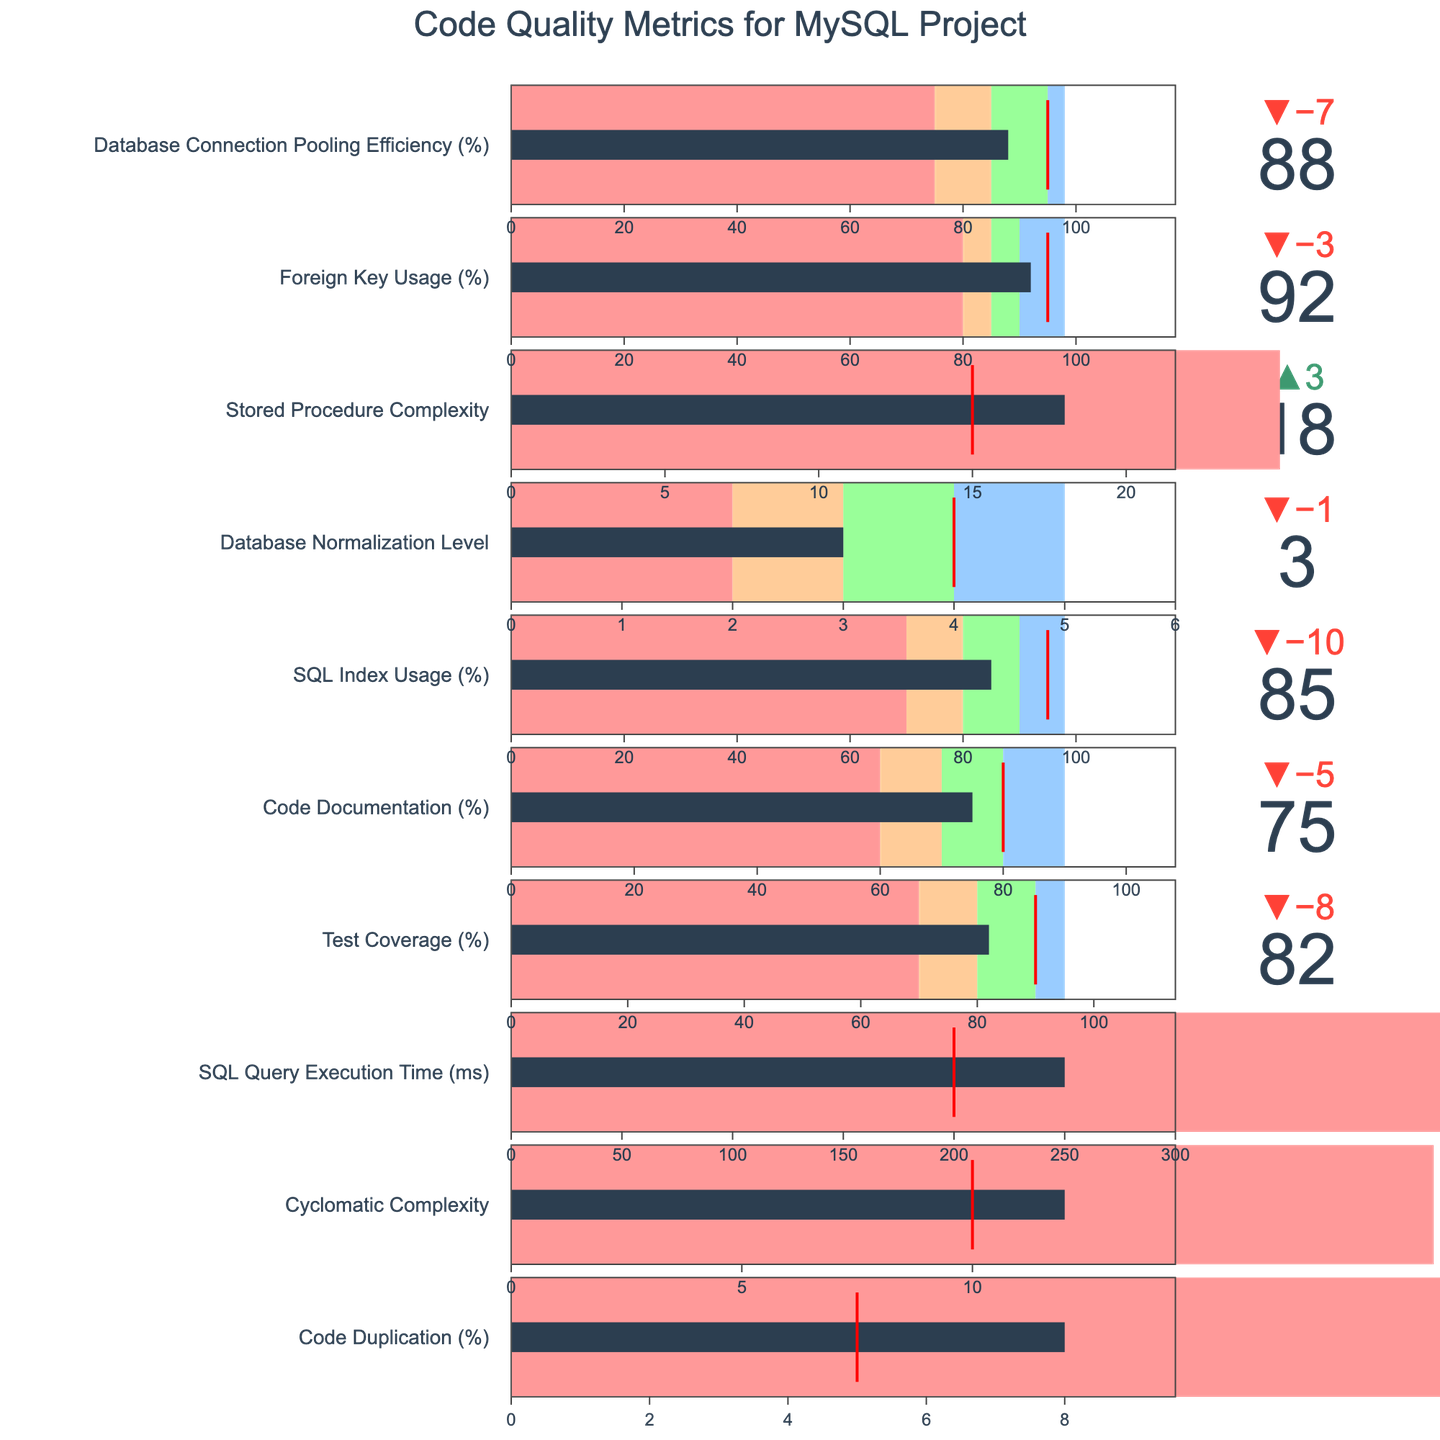What is the actual percentage of code duplication? The actual percentage of code duplication is displayed as the value on the "Code Duplication (%)" indicator within the figure.
Answer: 8% How does the actual cyclomatic complexity compare to the target? To compare, refer to the "Cyclomatic Complexity" indicator. The actual value is 12, while the target value is 10.
Answer: Higher What is the difference between the SQL Query Execution Time and its target? Look at the "SQL Query Execution Time (ms)" indicator. The actual execution time is 250 ms, and the target is 200 ms. Calculate the difference: 250 - 200 = 50 ms.
Answer: 50 ms How does the test coverage percentage stand in relation to being excellent? Check the "Test Coverage (%)" indicator. An excellent performance is above 95%, while the actual test coverage is 82%, which is below the excellent threshold.
Answer: Below Among the code quality metrics, which one has the closest actual value to its target? Examine each metric's actual and target values. The metric with the smallest difference is the "Cyclomatic Complexity" with values 12 (actual) and 10 (target).
Answer: Cyclomatic Complexity What ranges are used to categorize the SQL index usage? Investigate the "SQL Index Usage (%)" indicator. The categories are Poor (0-70%), Average (70-80%), Good (80-90%), and Excellent (90-98%).
Answer: Poor, Average, Good, Excellent Is database normalization exceeding, meeting, or below the target level? Look at "Database Normalization Level," where the actual level is 3, and the target is 4. Therefore, the actual level is below the target.
Answer: Below Which metric has the highest possible value for excellent performance? Observe all the indicators to find which has an "Excellent" category's highest value. "SQL Query Execution Time (ms)" has an excellent value capped at 100 ms.
Answer: SQL Query Execution Time What is the target value for foreign key usage in percentage terms? Refer to the "Foreign Key Usage (%)" indicator to find that the target value is 95%.
Answer: 95% How does the actual stored procedure complexity compare to its target? Check the "Stored Procedure Complexity" indicator. The actual complexity is 18, and the target complexity is 15, indicating that the actual is higher than the target.
Answer: Higher 